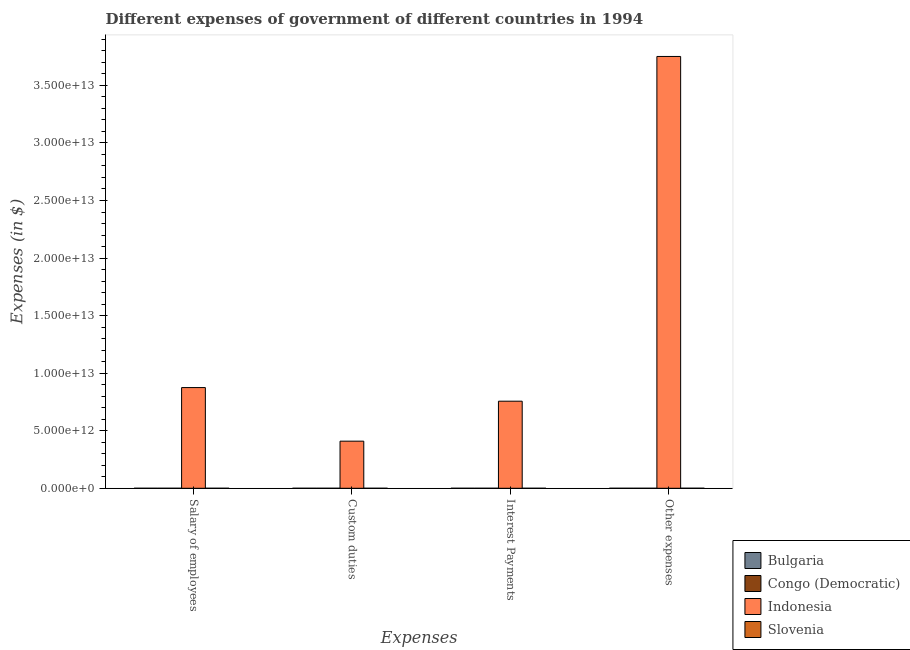How many different coloured bars are there?
Provide a succinct answer. 4. How many groups of bars are there?
Give a very brief answer. 4. Are the number of bars per tick equal to the number of legend labels?
Keep it short and to the point. Yes. How many bars are there on the 3rd tick from the left?
Ensure brevity in your answer.  4. What is the label of the 2nd group of bars from the left?
Your response must be concise. Custom duties. What is the amount spent on other expenses in Bulgaria?
Your answer should be very brief. 2.30e+08. Across all countries, what is the maximum amount spent on other expenses?
Your answer should be very brief. 3.75e+13. Across all countries, what is the minimum amount spent on salary of employees?
Offer a very short reply. 6.90e+05. In which country was the amount spent on custom duties maximum?
Offer a terse response. Indonesia. In which country was the amount spent on interest payments minimum?
Provide a short and direct response. Congo (Democratic). What is the total amount spent on other expenses in the graph?
Keep it short and to the point. 3.75e+13. What is the difference between the amount spent on interest payments in Bulgaria and that in Congo (Democratic)?
Ensure brevity in your answer.  7.60e+07. What is the difference between the amount spent on salary of employees in Indonesia and the amount spent on other expenses in Bulgaria?
Make the answer very short. 8.75e+12. What is the average amount spent on interest payments per country?
Make the answer very short. 1.89e+12. What is the difference between the amount spent on other expenses and amount spent on salary of employees in Congo (Democratic)?
Offer a terse response. 2.49e+06. What is the ratio of the amount spent on other expenses in Bulgaria to that in Indonesia?
Your answer should be compact. 6.125323238516701e-6. Is the amount spent on interest payments in Indonesia less than that in Slovenia?
Your answer should be very brief. No. What is the difference between the highest and the second highest amount spent on other expenses?
Offer a terse response. 3.75e+13. What is the difference between the highest and the lowest amount spent on custom duties?
Ensure brevity in your answer.  4.09e+12. What does the 4th bar from the left in Interest Payments represents?
Offer a terse response. Slovenia. What does the 4th bar from the right in Other expenses represents?
Provide a short and direct response. Bulgaria. Is it the case that in every country, the sum of the amount spent on salary of employees and amount spent on custom duties is greater than the amount spent on interest payments?
Provide a succinct answer. No. How many bars are there?
Offer a terse response. 16. How many countries are there in the graph?
Provide a short and direct response. 4. What is the difference between two consecutive major ticks on the Y-axis?
Offer a very short reply. 5.00e+12. How many legend labels are there?
Offer a terse response. 4. How are the legend labels stacked?
Your answer should be compact. Vertical. What is the title of the graph?
Provide a short and direct response. Different expenses of government of different countries in 1994. What is the label or title of the X-axis?
Give a very brief answer. Expenses. What is the label or title of the Y-axis?
Your answer should be very brief. Expenses (in $). What is the Expenses (in $) of Bulgaria in Salary of employees?
Your response must be concise. 1.36e+07. What is the Expenses (in $) of Congo (Democratic) in Salary of employees?
Your response must be concise. 6.90e+05. What is the Expenses (in $) of Indonesia in Salary of employees?
Your response must be concise. 8.75e+12. What is the Expenses (in $) in Slovenia in Salary of employees?
Your response must be concise. 5.54e+08. What is the Expenses (in $) of Bulgaria in Custom duties?
Your answer should be compact. 1.24e+07. What is the Expenses (in $) of Congo (Democratic) in Custom duties?
Provide a succinct answer. 7.11e+05. What is the Expenses (in $) of Indonesia in Custom duties?
Your answer should be very brief. 4.09e+12. What is the Expenses (in $) of Slovenia in Custom duties?
Your answer should be very brief. 2.68e+08. What is the Expenses (in $) in Bulgaria in Interest Payments?
Provide a succinct answer. 7.64e+07. What is the Expenses (in $) of Congo (Democratic) in Interest Payments?
Make the answer very short. 4.27e+05. What is the Expenses (in $) in Indonesia in Interest Payments?
Your response must be concise. 7.56e+12. What is the Expenses (in $) of Slovenia in Interest Payments?
Keep it short and to the point. 1.10e+08. What is the Expenses (in $) of Bulgaria in Other expenses?
Keep it short and to the point. 2.30e+08. What is the Expenses (in $) in Congo (Democratic) in Other expenses?
Provide a succinct answer. 3.18e+06. What is the Expenses (in $) in Indonesia in Other expenses?
Your answer should be compact. 3.75e+13. What is the Expenses (in $) of Slovenia in Other expenses?
Provide a succinct answer. 2.94e+09. Across all Expenses, what is the maximum Expenses (in $) in Bulgaria?
Your answer should be compact. 2.30e+08. Across all Expenses, what is the maximum Expenses (in $) in Congo (Democratic)?
Your answer should be compact. 3.18e+06. Across all Expenses, what is the maximum Expenses (in $) in Indonesia?
Your response must be concise. 3.75e+13. Across all Expenses, what is the maximum Expenses (in $) of Slovenia?
Provide a short and direct response. 2.94e+09. Across all Expenses, what is the minimum Expenses (in $) of Bulgaria?
Provide a succinct answer. 1.24e+07. Across all Expenses, what is the minimum Expenses (in $) in Congo (Democratic)?
Your answer should be very brief. 4.27e+05. Across all Expenses, what is the minimum Expenses (in $) of Indonesia?
Your answer should be very brief. 4.09e+12. Across all Expenses, what is the minimum Expenses (in $) in Slovenia?
Your answer should be compact. 1.10e+08. What is the total Expenses (in $) of Bulgaria in the graph?
Give a very brief answer. 3.32e+08. What is the total Expenses (in $) in Congo (Democratic) in the graph?
Ensure brevity in your answer.  5.01e+06. What is the total Expenses (in $) in Indonesia in the graph?
Your answer should be very brief. 5.79e+13. What is the total Expenses (in $) of Slovenia in the graph?
Provide a succinct answer. 3.87e+09. What is the difference between the Expenses (in $) in Bulgaria in Salary of employees and that in Custom duties?
Give a very brief answer. 1.18e+06. What is the difference between the Expenses (in $) in Congo (Democratic) in Salary of employees and that in Custom duties?
Keep it short and to the point. -2.06e+04. What is the difference between the Expenses (in $) in Indonesia in Salary of employees and that in Custom duties?
Make the answer very short. 4.66e+12. What is the difference between the Expenses (in $) in Slovenia in Salary of employees and that in Custom duties?
Give a very brief answer. 2.86e+08. What is the difference between the Expenses (in $) of Bulgaria in Salary of employees and that in Interest Payments?
Offer a very short reply. -6.28e+07. What is the difference between the Expenses (in $) in Congo (Democratic) in Salary of employees and that in Interest Payments?
Your answer should be compact. 2.63e+05. What is the difference between the Expenses (in $) in Indonesia in Salary of employees and that in Interest Payments?
Offer a very short reply. 1.18e+12. What is the difference between the Expenses (in $) of Slovenia in Salary of employees and that in Interest Payments?
Offer a very short reply. 4.44e+08. What is the difference between the Expenses (in $) in Bulgaria in Salary of employees and that in Other expenses?
Provide a short and direct response. -2.16e+08. What is the difference between the Expenses (in $) of Congo (Democratic) in Salary of employees and that in Other expenses?
Offer a terse response. -2.49e+06. What is the difference between the Expenses (in $) in Indonesia in Salary of employees and that in Other expenses?
Offer a very short reply. -2.88e+13. What is the difference between the Expenses (in $) in Slovenia in Salary of employees and that in Other expenses?
Ensure brevity in your answer.  -2.38e+09. What is the difference between the Expenses (in $) in Bulgaria in Custom duties and that in Interest Payments?
Offer a very short reply. -6.40e+07. What is the difference between the Expenses (in $) of Congo (Democratic) in Custom duties and that in Interest Payments?
Provide a succinct answer. 2.84e+05. What is the difference between the Expenses (in $) of Indonesia in Custom duties and that in Interest Payments?
Your response must be concise. -3.47e+12. What is the difference between the Expenses (in $) of Slovenia in Custom duties and that in Interest Payments?
Your answer should be very brief. 1.58e+08. What is the difference between the Expenses (in $) in Bulgaria in Custom duties and that in Other expenses?
Offer a terse response. -2.17e+08. What is the difference between the Expenses (in $) in Congo (Democratic) in Custom duties and that in Other expenses?
Provide a succinct answer. -2.47e+06. What is the difference between the Expenses (in $) of Indonesia in Custom duties and that in Other expenses?
Provide a short and direct response. -3.34e+13. What is the difference between the Expenses (in $) in Slovenia in Custom duties and that in Other expenses?
Your answer should be compact. -2.67e+09. What is the difference between the Expenses (in $) of Bulgaria in Interest Payments and that in Other expenses?
Keep it short and to the point. -1.53e+08. What is the difference between the Expenses (in $) of Congo (Democratic) in Interest Payments and that in Other expenses?
Your response must be concise. -2.75e+06. What is the difference between the Expenses (in $) in Indonesia in Interest Payments and that in Other expenses?
Ensure brevity in your answer.  -2.99e+13. What is the difference between the Expenses (in $) in Slovenia in Interest Payments and that in Other expenses?
Your answer should be very brief. -2.83e+09. What is the difference between the Expenses (in $) in Bulgaria in Salary of employees and the Expenses (in $) in Congo (Democratic) in Custom duties?
Keep it short and to the point. 1.29e+07. What is the difference between the Expenses (in $) in Bulgaria in Salary of employees and the Expenses (in $) in Indonesia in Custom duties?
Your answer should be very brief. -4.09e+12. What is the difference between the Expenses (in $) of Bulgaria in Salary of employees and the Expenses (in $) of Slovenia in Custom duties?
Offer a terse response. -2.55e+08. What is the difference between the Expenses (in $) of Congo (Democratic) in Salary of employees and the Expenses (in $) of Indonesia in Custom duties?
Keep it short and to the point. -4.09e+12. What is the difference between the Expenses (in $) in Congo (Democratic) in Salary of employees and the Expenses (in $) in Slovenia in Custom duties?
Your answer should be compact. -2.68e+08. What is the difference between the Expenses (in $) of Indonesia in Salary of employees and the Expenses (in $) of Slovenia in Custom duties?
Provide a succinct answer. 8.75e+12. What is the difference between the Expenses (in $) in Bulgaria in Salary of employees and the Expenses (in $) in Congo (Democratic) in Interest Payments?
Keep it short and to the point. 1.32e+07. What is the difference between the Expenses (in $) of Bulgaria in Salary of employees and the Expenses (in $) of Indonesia in Interest Payments?
Provide a succinct answer. -7.56e+12. What is the difference between the Expenses (in $) of Bulgaria in Salary of employees and the Expenses (in $) of Slovenia in Interest Payments?
Offer a very short reply. -9.65e+07. What is the difference between the Expenses (in $) of Congo (Democratic) in Salary of employees and the Expenses (in $) of Indonesia in Interest Payments?
Provide a short and direct response. -7.56e+12. What is the difference between the Expenses (in $) in Congo (Democratic) in Salary of employees and the Expenses (in $) in Slovenia in Interest Payments?
Your answer should be compact. -1.09e+08. What is the difference between the Expenses (in $) of Indonesia in Salary of employees and the Expenses (in $) of Slovenia in Interest Payments?
Your answer should be very brief. 8.75e+12. What is the difference between the Expenses (in $) of Bulgaria in Salary of employees and the Expenses (in $) of Congo (Democratic) in Other expenses?
Provide a succinct answer. 1.04e+07. What is the difference between the Expenses (in $) in Bulgaria in Salary of employees and the Expenses (in $) in Indonesia in Other expenses?
Offer a very short reply. -3.75e+13. What is the difference between the Expenses (in $) in Bulgaria in Salary of employees and the Expenses (in $) in Slovenia in Other expenses?
Give a very brief answer. -2.92e+09. What is the difference between the Expenses (in $) in Congo (Democratic) in Salary of employees and the Expenses (in $) in Indonesia in Other expenses?
Provide a succinct answer. -3.75e+13. What is the difference between the Expenses (in $) in Congo (Democratic) in Salary of employees and the Expenses (in $) in Slovenia in Other expenses?
Keep it short and to the point. -2.94e+09. What is the difference between the Expenses (in $) in Indonesia in Salary of employees and the Expenses (in $) in Slovenia in Other expenses?
Keep it short and to the point. 8.75e+12. What is the difference between the Expenses (in $) of Bulgaria in Custom duties and the Expenses (in $) of Congo (Democratic) in Interest Payments?
Your answer should be compact. 1.20e+07. What is the difference between the Expenses (in $) of Bulgaria in Custom duties and the Expenses (in $) of Indonesia in Interest Payments?
Your answer should be very brief. -7.56e+12. What is the difference between the Expenses (in $) in Bulgaria in Custom duties and the Expenses (in $) in Slovenia in Interest Payments?
Your answer should be very brief. -9.77e+07. What is the difference between the Expenses (in $) of Congo (Democratic) in Custom duties and the Expenses (in $) of Indonesia in Interest Payments?
Your response must be concise. -7.56e+12. What is the difference between the Expenses (in $) of Congo (Democratic) in Custom duties and the Expenses (in $) of Slovenia in Interest Payments?
Offer a very short reply. -1.09e+08. What is the difference between the Expenses (in $) in Indonesia in Custom duties and the Expenses (in $) in Slovenia in Interest Payments?
Your answer should be compact. 4.09e+12. What is the difference between the Expenses (in $) in Bulgaria in Custom duties and the Expenses (in $) in Congo (Democratic) in Other expenses?
Offer a very short reply. 9.26e+06. What is the difference between the Expenses (in $) in Bulgaria in Custom duties and the Expenses (in $) in Indonesia in Other expenses?
Provide a succinct answer. -3.75e+13. What is the difference between the Expenses (in $) of Bulgaria in Custom duties and the Expenses (in $) of Slovenia in Other expenses?
Your response must be concise. -2.92e+09. What is the difference between the Expenses (in $) in Congo (Democratic) in Custom duties and the Expenses (in $) in Indonesia in Other expenses?
Offer a terse response. -3.75e+13. What is the difference between the Expenses (in $) in Congo (Democratic) in Custom duties and the Expenses (in $) in Slovenia in Other expenses?
Give a very brief answer. -2.94e+09. What is the difference between the Expenses (in $) in Indonesia in Custom duties and the Expenses (in $) in Slovenia in Other expenses?
Make the answer very short. 4.09e+12. What is the difference between the Expenses (in $) of Bulgaria in Interest Payments and the Expenses (in $) of Congo (Democratic) in Other expenses?
Keep it short and to the point. 7.32e+07. What is the difference between the Expenses (in $) of Bulgaria in Interest Payments and the Expenses (in $) of Indonesia in Other expenses?
Give a very brief answer. -3.75e+13. What is the difference between the Expenses (in $) of Bulgaria in Interest Payments and the Expenses (in $) of Slovenia in Other expenses?
Make the answer very short. -2.86e+09. What is the difference between the Expenses (in $) of Congo (Democratic) in Interest Payments and the Expenses (in $) of Indonesia in Other expenses?
Offer a terse response. -3.75e+13. What is the difference between the Expenses (in $) of Congo (Democratic) in Interest Payments and the Expenses (in $) of Slovenia in Other expenses?
Give a very brief answer. -2.94e+09. What is the difference between the Expenses (in $) of Indonesia in Interest Payments and the Expenses (in $) of Slovenia in Other expenses?
Give a very brief answer. 7.56e+12. What is the average Expenses (in $) in Bulgaria per Expenses?
Offer a very short reply. 8.31e+07. What is the average Expenses (in $) of Congo (Democratic) per Expenses?
Your answer should be very brief. 1.25e+06. What is the average Expenses (in $) in Indonesia per Expenses?
Keep it short and to the point. 1.45e+13. What is the average Expenses (in $) in Slovenia per Expenses?
Ensure brevity in your answer.  9.67e+08. What is the difference between the Expenses (in $) in Bulgaria and Expenses (in $) in Congo (Democratic) in Salary of employees?
Provide a short and direct response. 1.29e+07. What is the difference between the Expenses (in $) in Bulgaria and Expenses (in $) in Indonesia in Salary of employees?
Provide a short and direct response. -8.75e+12. What is the difference between the Expenses (in $) of Bulgaria and Expenses (in $) of Slovenia in Salary of employees?
Give a very brief answer. -5.41e+08. What is the difference between the Expenses (in $) in Congo (Democratic) and Expenses (in $) in Indonesia in Salary of employees?
Make the answer very short. -8.75e+12. What is the difference between the Expenses (in $) of Congo (Democratic) and Expenses (in $) of Slovenia in Salary of employees?
Your answer should be very brief. -5.53e+08. What is the difference between the Expenses (in $) in Indonesia and Expenses (in $) in Slovenia in Salary of employees?
Your answer should be very brief. 8.75e+12. What is the difference between the Expenses (in $) of Bulgaria and Expenses (in $) of Congo (Democratic) in Custom duties?
Keep it short and to the point. 1.17e+07. What is the difference between the Expenses (in $) of Bulgaria and Expenses (in $) of Indonesia in Custom duties?
Your response must be concise. -4.09e+12. What is the difference between the Expenses (in $) in Bulgaria and Expenses (in $) in Slovenia in Custom duties?
Offer a very short reply. -2.56e+08. What is the difference between the Expenses (in $) in Congo (Democratic) and Expenses (in $) in Indonesia in Custom duties?
Keep it short and to the point. -4.09e+12. What is the difference between the Expenses (in $) in Congo (Democratic) and Expenses (in $) in Slovenia in Custom duties?
Ensure brevity in your answer.  -2.68e+08. What is the difference between the Expenses (in $) in Indonesia and Expenses (in $) in Slovenia in Custom duties?
Your answer should be very brief. 4.09e+12. What is the difference between the Expenses (in $) of Bulgaria and Expenses (in $) of Congo (Democratic) in Interest Payments?
Offer a very short reply. 7.60e+07. What is the difference between the Expenses (in $) of Bulgaria and Expenses (in $) of Indonesia in Interest Payments?
Offer a very short reply. -7.56e+12. What is the difference between the Expenses (in $) in Bulgaria and Expenses (in $) in Slovenia in Interest Payments?
Your response must be concise. -3.38e+07. What is the difference between the Expenses (in $) in Congo (Democratic) and Expenses (in $) in Indonesia in Interest Payments?
Give a very brief answer. -7.56e+12. What is the difference between the Expenses (in $) in Congo (Democratic) and Expenses (in $) in Slovenia in Interest Payments?
Make the answer very short. -1.10e+08. What is the difference between the Expenses (in $) of Indonesia and Expenses (in $) of Slovenia in Interest Payments?
Provide a short and direct response. 7.56e+12. What is the difference between the Expenses (in $) of Bulgaria and Expenses (in $) of Congo (Democratic) in Other expenses?
Your response must be concise. 2.27e+08. What is the difference between the Expenses (in $) of Bulgaria and Expenses (in $) of Indonesia in Other expenses?
Give a very brief answer. -3.75e+13. What is the difference between the Expenses (in $) of Bulgaria and Expenses (in $) of Slovenia in Other expenses?
Offer a terse response. -2.71e+09. What is the difference between the Expenses (in $) in Congo (Democratic) and Expenses (in $) in Indonesia in Other expenses?
Your answer should be very brief. -3.75e+13. What is the difference between the Expenses (in $) of Congo (Democratic) and Expenses (in $) of Slovenia in Other expenses?
Give a very brief answer. -2.93e+09. What is the difference between the Expenses (in $) in Indonesia and Expenses (in $) in Slovenia in Other expenses?
Ensure brevity in your answer.  3.75e+13. What is the ratio of the Expenses (in $) of Bulgaria in Salary of employees to that in Custom duties?
Keep it short and to the point. 1.1. What is the ratio of the Expenses (in $) in Congo (Democratic) in Salary of employees to that in Custom duties?
Provide a succinct answer. 0.97. What is the ratio of the Expenses (in $) of Indonesia in Salary of employees to that in Custom duties?
Keep it short and to the point. 2.14. What is the ratio of the Expenses (in $) of Slovenia in Salary of employees to that in Custom duties?
Your answer should be compact. 2.07. What is the ratio of the Expenses (in $) of Bulgaria in Salary of employees to that in Interest Payments?
Your answer should be very brief. 0.18. What is the ratio of the Expenses (in $) in Congo (Democratic) in Salary of employees to that in Interest Payments?
Keep it short and to the point. 1.62. What is the ratio of the Expenses (in $) of Indonesia in Salary of employees to that in Interest Payments?
Keep it short and to the point. 1.16. What is the ratio of the Expenses (in $) in Slovenia in Salary of employees to that in Interest Payments?
Offer a very short reply. 5.03. What is the ratio of the Expenses (in $) in Bulgaria in Salary of employees to that in Other expenses?
Your answer should be compact. 0.06. What is the ratio of the Expenses (in $) in Congo (Democratic) in Salary of employees to that in Other expenses?
Offer a terse response. 0.22. What is the ratio of the Expenses (in $) of Indonesia in Salary of employees to that in Other expenses?
Your response must be concise. 0.23. What is the ratio of the Expenses (in $) in Slovenia in Salary of employees to that in Other expenses?
Ensure brevity in your answer.  0.19. What is the ratio of the Expenses (in $) of Bulgaria in Custom duties to that in Interest Payments?
Your answer should be compact. 0.16. What is the ratio of the Expenses (in $) in Congo (Democratic) in Custom duties to that in Interest Payments?
Your answer should be compact. 1.66. What is the ratio of the Expenses (in $) in Indonesia in Custom duties to that in Interest Payments?
Ensure brevity in your answer.  0.54. What is the ratio of the Expenses (in $) in Slovenia in Custom duties to that in Interest Payments?
Your answer should be compact. 2.44. What is the ratio of the Expenses (in $) of Bulgaria in Custom duties to that in Other expenses?
Provide a succinct answer. 0.05. What is the ratio of the Expenses (in $) in Congo (Democratic) in Custom duties to that in Other expenses?
Provide a short and direct response. 0.22. What is the ratio of the Expenses (in $) in Indonesia in Custom duties to that in Other expenses?
Keep it short and to the point. 0.11. What is the ratio of the Expenses (in $) of Slovenia in Custom duties to that in Other expenses?
Provide a short and direct response. 0.09. What is the ratio of the Expenses (in $) of Bulgaria in Interest Payments to that in Other expenses?
Your answer should be compact. 0.33. What is the ratio of the Expenses (in $) of Congo (Democratic) in Interest Payments to that in Other expenses?
Make the answer very short. 0.13. What is the ratio of the Expenses (in $) in Indonesia in Interest Payments to that in Other expenses?
Make the answer very short. 0.2. What is the ratio of the Expenses (in $) in Slovenia in Interest Payments to that in Other expenses?
Make the answer very short. 0.04. What is the difference between the highest and the second highest Expenses (in $) of Bulgaria?
Provide a succinct answer. 1.53e+08. What is the difference between the highest and the second highest Expenses (in $) of Congo (Democratic)?
Your answer should be very brief. 2.47e+06. What is the difference between the highest and the second highest Expenses (in $) of Indonesia?
Give a very brief answer. 2.88e+13. What is the difference between the highest and the second highest Expenses (in $) in Slovenia?
Your response must be concise. 2.38e+09. What is the difference between the highest and the lowest Expenses (in $) in Bulgaria?
Ensure brevity in your answer.  2.17e+08. What is the difference between the highest and the lowest Expenses (in $) of Congo (Democratic)?
Your response must be concise. 2.75e+06. What is the difference between the highest and the lowest Expenses (in $) in Indonesia?
Provide a short and direct response. 3.34e+13. What is the difference between the highest and the lowest Expenses (in $) of Slovenia?
Offer a terse response. 2.83e+09. 